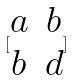Convert formula to latex. <formula><loc_0><loc_0><loc_500><loc_500>[ \begin{matrix} a & b \\ b & d \end{matrix} ]</formula> 